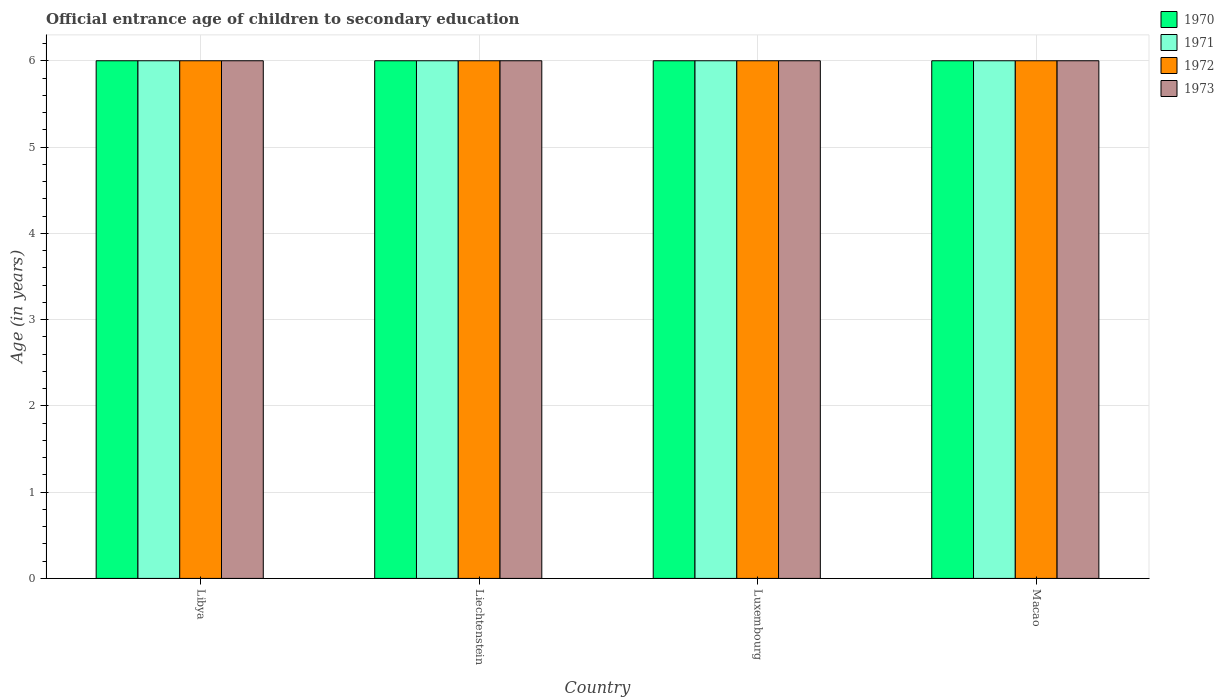How many different coloured bars are there?
Offer a terse response. 4. How many groups of bars are there?
Keep it short and to the point. 4. How many bars are there on the 3rd tick from the left?
Ensure brevity in your answer.  4. What is the label of the 3rd group of bars from the left?
Offer a very short reply. Luxembourg. Across all countries, what is the maximum secondary school starting age of children in 1971?
Your answer should be compact. 6. In which country was the secondary school starting age of children in 1970 maximum?
Your response must be concise. Libya. In which country was the secondary school starting age of children in 1970 minimum?
Make the answer very short. Libya. What is the average secondary school starting age of children in 1970 per country?
Your answer should be compact. 6. What is the difference between the secondary school starting age of children of/in 1971 and secondary school starting age of children of/in 1973 in Luxembourg?
Offer a very short reply. 0. In how many countries, is the secondary school starting age of children in 1972 greater than 4.2 years?
Offer a terse response. 4. Is the secondary school starting age of children in 1971 in Liechtenstein less than that in Luxembourg?
Offer a terse response. No. Is the difference between the secondary school starting age of children in 1971 in Luxembourg and Macao greater than the difference between the secondary school starting age of children in 1973 in Luxembourg and Macao?
Give a very brief answer. No. In how many countries, is the secondary school starting age of children in 1972 greater than the average secondary school starting age of children in 1972 taken over all countries?
Your answer should be compact. 0. Is the sum of the secondary school starting age of children in 1971 in Libya and Macao greater than the maximum secondary school starting age of children in 1973 across all countries?
Offer a very short reply. Yes. What does the 2nd bar from the right in Macao represents?
Ensure brevity in your answer.  1972. Is it the case that in every country, the sum of the secondary school starting age of children in 1973 and secondary school starting age of children in 1971 is greater than the secondary school starting age of children in 1972?
Your response must be concise. Yes. How many bars are there?
Keep it short and to the point. 16. What is the difference between two consecutive major ticks on the Y-axis?
Provide a succinct answer. 1. Are the values on the major ticks of Y-axis written in scientific E-notation?
Provide a short and direct response. No. Does the graph contain any zero values?
Give a very brief answer. No. Does the graph contain grids?
Make the answer very short. Yes. Where does the legend appear in the graph?
Provide a succinct answer. Top right. How many legend labels are there?
Your response must be concise. 4. What is the title of the graph?
Ensure brevity in your answer.  Official entrance age of children to secondary education. Does "1982" appear as one of the legend labels in the graph?
Provide a succinct answer. No. What is the label or title of the X-axis?
Give a very brief answer. Country. What is the label or title of the Y-axis?
Ensure brevity in your answer.  Age (in years). What is the Age (in years) of 1971 in Libya?
Give a very brief answer. 6. What is the Age (in years) of 1972 in Libya?
Offer a terse response. 6. What is the Age (in years) in 1973 in Libya?
Your response must be concise. 6. What is the Age (in years) of 1970 in Liechtenstein?
Keep it short and to the point. 6. What is the Age (in years) in 1970 in Luxembourg?
Offer a very short reply. 6. What is the Age (in years) in 1971 in Luxembourg?
Provide a succinct answer. 6. What is the Age (in years) in 1973 in Luxembourg?
Provide a short and direct response. 6. What is the Age (in years) of 1970 in Macao?
Your answer should be very brief. 6. What is the Age (in years) of 1972 in Macao?
Ensure brevity in your answer.  6. What is the Age (in years) in 1973 in Macao?
Provide a short and direct response. 6. Across all countries, what is the maximum Age (in years) of 1971?
Your response must be concise. 6. Across all countries, what is the maximum Age (in years) in 1972?
Your response must be concise. 6. Across all countries, what is the maximum Age (in years) in 1973?
Offer a terse response. 6. Across all countries, what is the minimum Age (in years) of 1970?
Keep it short and to the point. 6. Across all countries, what is the minimum Age (in years) of 1972?
Your response must be concise. 6. Across all countries, what is the minimum Age (in years) in 1973?
Your answer should be compact. 6. What is the total Age (in years) in 1971 in the graph?
Provide a succinct answer. 24. What is the total Age (in years) in 1972 in the graph?
Give a very brief answer. 24. What is the total Age (in years) in 1973 in the graph?
Keep it short and to the point. 24. What is the difference between the Age (in years) in 1970 in Libya and that in Liechtenstein?
Provide a short and direct response. 0. What is the difference between the Age (in years) of 1972 in Libya and that in Liechtenstein?
Keep it short and to the point. 0. What is the difference between the Age (in years) in 1973 in Libya and that in Liechtenstein?
Offer a very short reply. 0. What is the difference between the Age (in years) of 1970 in Libya and that in Luxembourg?
Make the answer very short. 0. What is the difference between the Age (in years) of 1971 in Libya and that in Luxembourg?
Give a very brief answer. 0. What is the difference between the Age (in years) of 1972 in Libya and that in Luxembourg?
Your answer should be compact. 0. What is the difference between the Age (in years) of 1973 in Libya and that in Luxembourg?
Keep it short and to the point. 0. What is the difference between the Age (in years) of 1970 in Libya and that in Macao?
Give a very brief answer. 0. What is the difference between the Age (in years) of 1971 in Libya and that in Macao?
Your response must be concise. 0. What is the difference between the Age (in years) in 1973 in Libya and that in Macao?
Offer a terse response. 0. What is the difference between the Age (in years) of 1971 in Liechtenstein and that in Luxembourg?
Keep it short and to the point. 0. What is the difference between the Age (in years) in 1971 in Liechtenstein and that in Macao?
Make the answer very short. 0. What is the difference between the Age (in years) of 1972 in Liechtenstein and that in Macao?
Offer a terse response. 0. What is the difference between the Age (in years) of 1970 in Luxembourg and that in Macao?
Your answer should be compact. 0. What is the difference between the Age (in years) of 1971 in Luxembourg and that in Macao?
Keep it short and to the point. 0. What is the difference between the Age (in years) in 1972 in Luxembourg and that in Macao?
Ensure brevity in your answer.  0. What is the difference between the Age (in years) of 1973 in Luxembourg and that in Macao?
Your response must be concise. 0. What is the difference between the Age (in years) of 1970 in Libya and the Age (in years) of 1972 in Liechtenstein?
Offer a very short reply. 0. What is the difference between the Age (in years) in 1970 in Libya and the Age (in years) in 1973 in Liechtenstein?
Your answer should be compact. 0. What is the difference between the Age (in years) of 1970 in Libya and the Age (in years) of 1971 in Luxembourg?
Your answer should be very brief. 0. What is the difference between the Age (in years) of 1970 in Libya and the Age (in years) of 1973 in Luxembourg?
Provide a short and direct response. 0. What is the difference between the Age (in years) in 1972 in Libya and the Age (in years) in 1973 in Luxembourg?
Make the answer very short. 0. What is the difference between the Age (in years) of 1972 in Libya and the Age (in years) of 1973 in Macao?
Ensure brevity in your answer.  0. What is the difference between the Age (in years) in 1970 in Liechtenstein and the Age (in years) in 1971 in Luxembourg?
Make the answer very short. 0. What is the difference between the Age (in years) in 1971 in Liechtenstein and the Age (in years) in 1972 in Luxembourg?
Offer a terse response. 0. What is the difference between the Age (in years) of 1970 in Liechtenstein and the Age (in years) of 1971 in Macao?
Give a very brief answer. 0. What is the difference between the Age (in years) in 1970 in Liechtenstein and the Age (in years) in 1972 in Macao?
Your response must be concise. 0. What is the difference between the Age (in years) in 1971 in Liechtenstein and the Age (in years) in 1972 in Macao?
Keep it short and to the point. 0. What is the difference between the Age (in years) in 1972 in Liechtenstein and the Age (in years) in 1973 in Macao?
Your response must be concise. 0. What is the difference between the Age (in years) of 1972 in Luxembourg and the Age (in years) of 1973 in Macao?
Your answer should be very brief. 0. What is the average Age (in years) of 1970 per country?
Provide a succinct answer. 6. What is the average Age (in years) in 1971 per country?
Offer a terse response. 6. What is the average Age (in years) in 1972 per country?
Offer a very short reply. 6. What is the difference between the Age (in years) in 1970 and Age (in years) in 1972 in Libya?
Provide a succinct answer. 0. What is the difference between the Age (in years) in 1971 and Age (in years) in 1972 in Libya?
Your answer should be very brief. 0. What is the difference between the Age (in years) in 1971 and Age (in years) in 1973 in Libya?
Provide a short and direct response. 0. What is the difference between the Age (in years) in 1972 and Age (in years) in 1973 in Libya?
Offer a very short reply. 0. What is the difference between the Age (in years) of 1971 and Age (in years) of 1972 in Liechtenstein?
Offer a very short reply. 0. What is the difference between the Age (in years) in 1970 and Age (in years) in 1973 in Luxembourg?
Ensure brevity in your answer.  0. What is the difference between the Age (in years) in 1971 and Age (in years) in 1972 in Luxembourg?
Your response must be concise. 0. What is the difference between the Age (in years) in 1972 and Age (in years) in 1973 in Luxembourg?
Offer a terse response. 0. What is the difference between the Age (in years) of 1970 and Age (in years) of 1971 in Macao?
Provide a short and direct response. 0. What is the difference between the Age (in years) of 1970 and Age (in years) of 1972 in Macao?
Provide a short and direct response. 0. What is the difference between the Age (in years) of 1971 and Age (in years) of 1972 in Macao?
Keep it short and to the point. 0. What is the difference between the Age (in years) of 1971 and Age (in years) of 1973 in Macao?
Ensure brevity in your answer.  0. What is the difference between the Age (in years) of 1972 and Age (in years) of 1973 in Macao?
Provide a short and direct response. 0. What is the ratio of the Age (in years) in 1971 in Libya to that in Liechtenstein?
Give a very brief answer. 1. What is the ratio of the Age (in years) in 1972 in Libya to that in Liechtenstein?
Keep it short and to the point. 1. What is the ratio of the Age (in years) of 1973 in Libya to that in Liechtenstein?
Keep it short and to the point. 1. What is the ratio of the Age (in years) in 1970 in Libya to that in Luxembourg?
Keep it short and to the point. 1. What is the ratio of the Age (in years) in 1971 in Libya to that in Luxembourg?
Provide a short and direct response. 1. What is the ratio of the Age (in years) of 1972 in Libya to that in Luxembourg?
Give a very brief answer. 1. What is the ratio of the Age (in years) in 1973 in Libya to that in Luxembourg?
Ensure brevity in your answer.  1. What is the ratio of the Age (in years) of 1970 in Libya to that in Macao?
Your answer should be very brief. 1. What is the ratio of the Age (in years) in 1971 in Libya to that in Macao?
Your answer should be very brief. 1. What is the ratio of the Age (in years) in 1972 in Libya to that in Macao?
Your answer should be very brief. 1. What is the ratio of the Age (in years) of 1970 in Liechtenstein to that in Luxembourg?
Your answer should be compact. 1. What is the ratio of the Age (in years) of 1972 in Liechtenstein to that in Luxembourg?
Your response must be concise. 1. What is the ratio of the Age (in years) in 1973 in Liechtenstein to that in Luxembourg?
Provide a succinct answer. 1. What is the ratio of the Age (in years) in 1970 in Liechtenstein to that in Macao?
Offer a very short reply. 1. What is the ratio of the Age (in years) of 1973 in Liechtenstein to that in Macao?
Offer a terse response. 1. What is the ratio of the Age (in years) in 1970 in Luxembourg to that in Macao?
Provide a short and direct response. 1. What is the ratio of the Age (in years) in 1971 in Luxembourg to that in Macao?
Keep it short and to the point. 1. What is the ratio of the Age (in years) in 1972 in Luxembourg to that in Macao?
Provide a succinct answer. 1. What is the difference between the highest and the second highest Age (in years) of 1971?
Your response must be concise. 0. What is the difference between the highest and the lowest Age (in years) in 1972?
Make the answer very short. 0. 